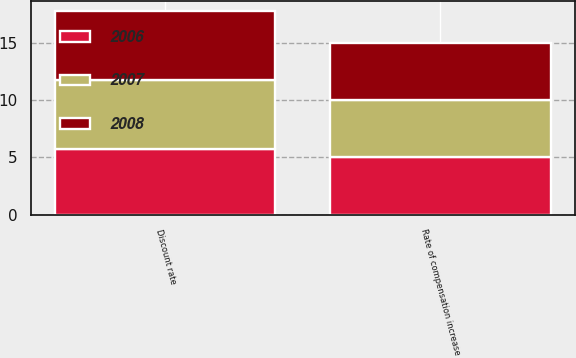Convert chart. <chart><loc_0><loc_0><loc_500><loc_500><stacked_bar_chart><ecel><fcel>Discount rate<fcel>Rate of compensation increase<nl><fcel>2007<fcel>6<fcel>5<nl><fcel>2008<fcel>6<fcel>5<nl><fcel>2006<fcel>5.75<fcel>5<nl></chart> 